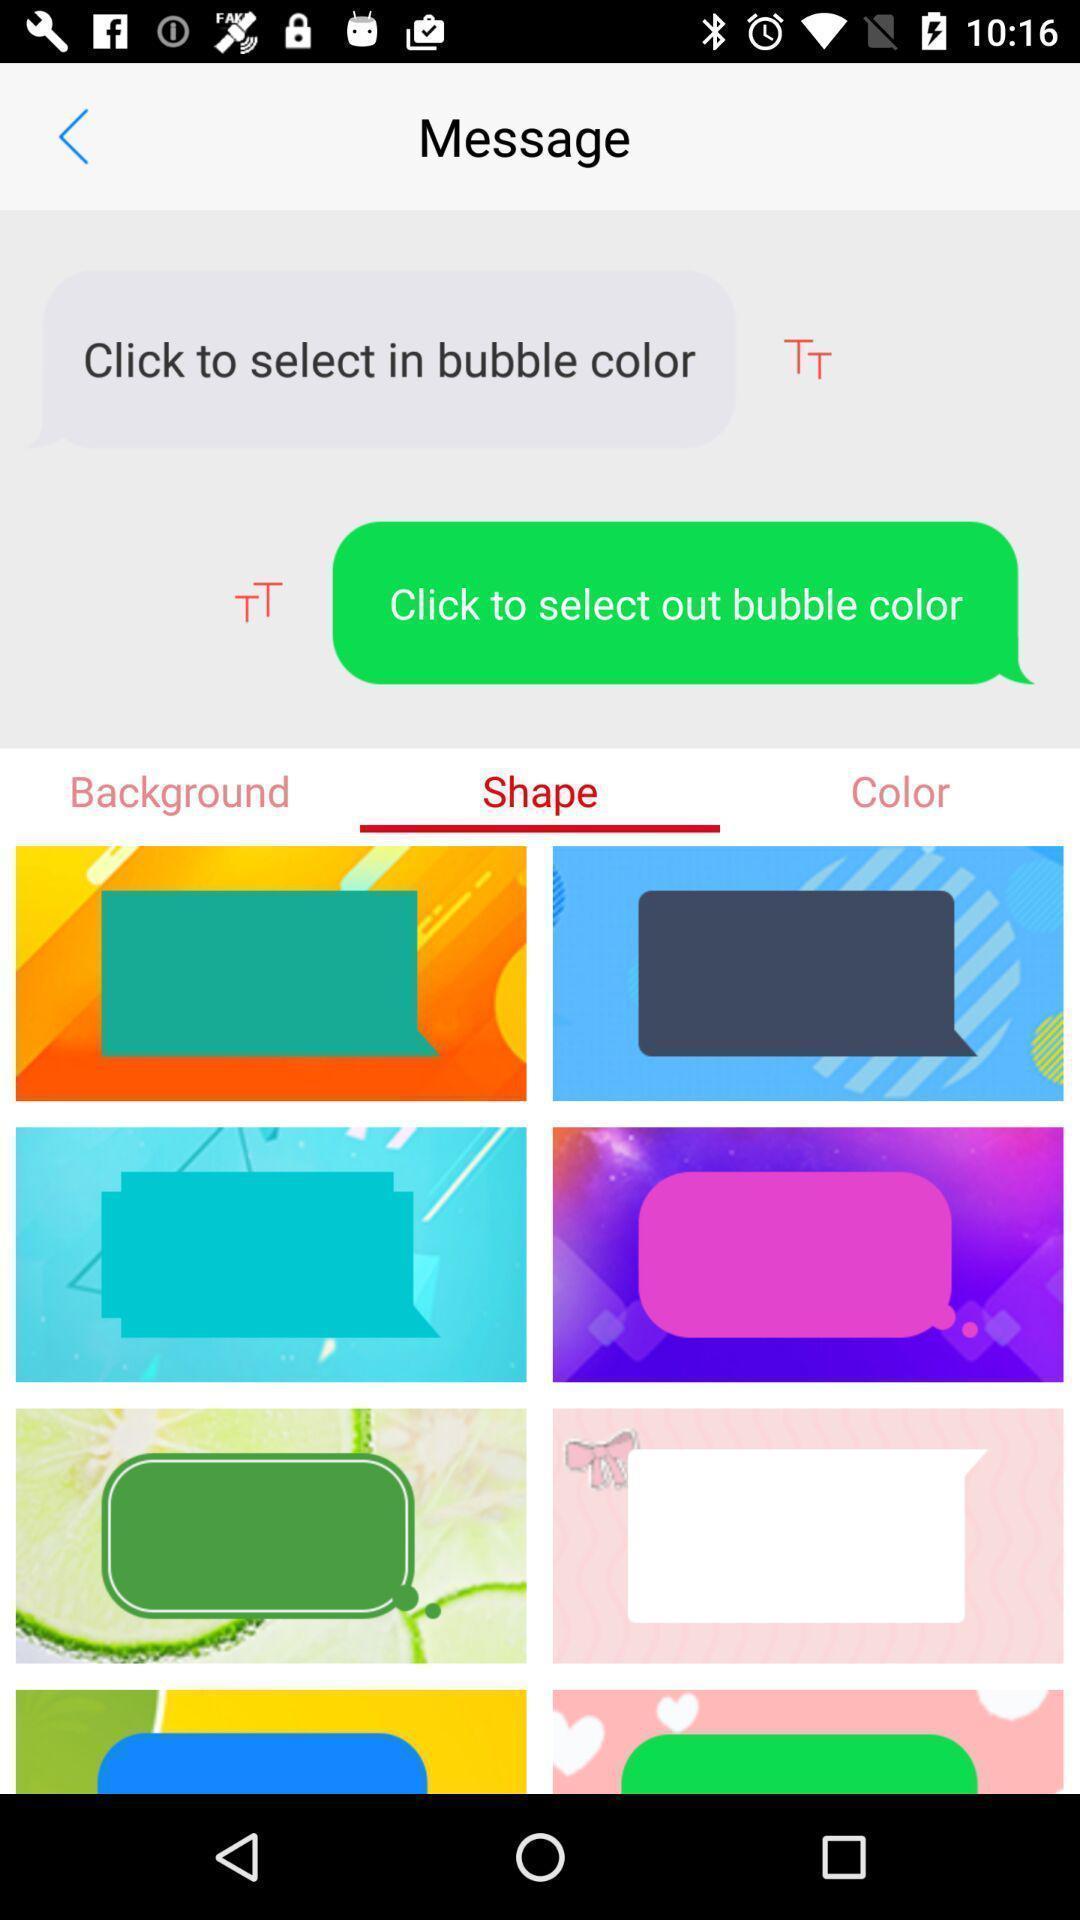Describe this image in words. Screen displaying the message page. 